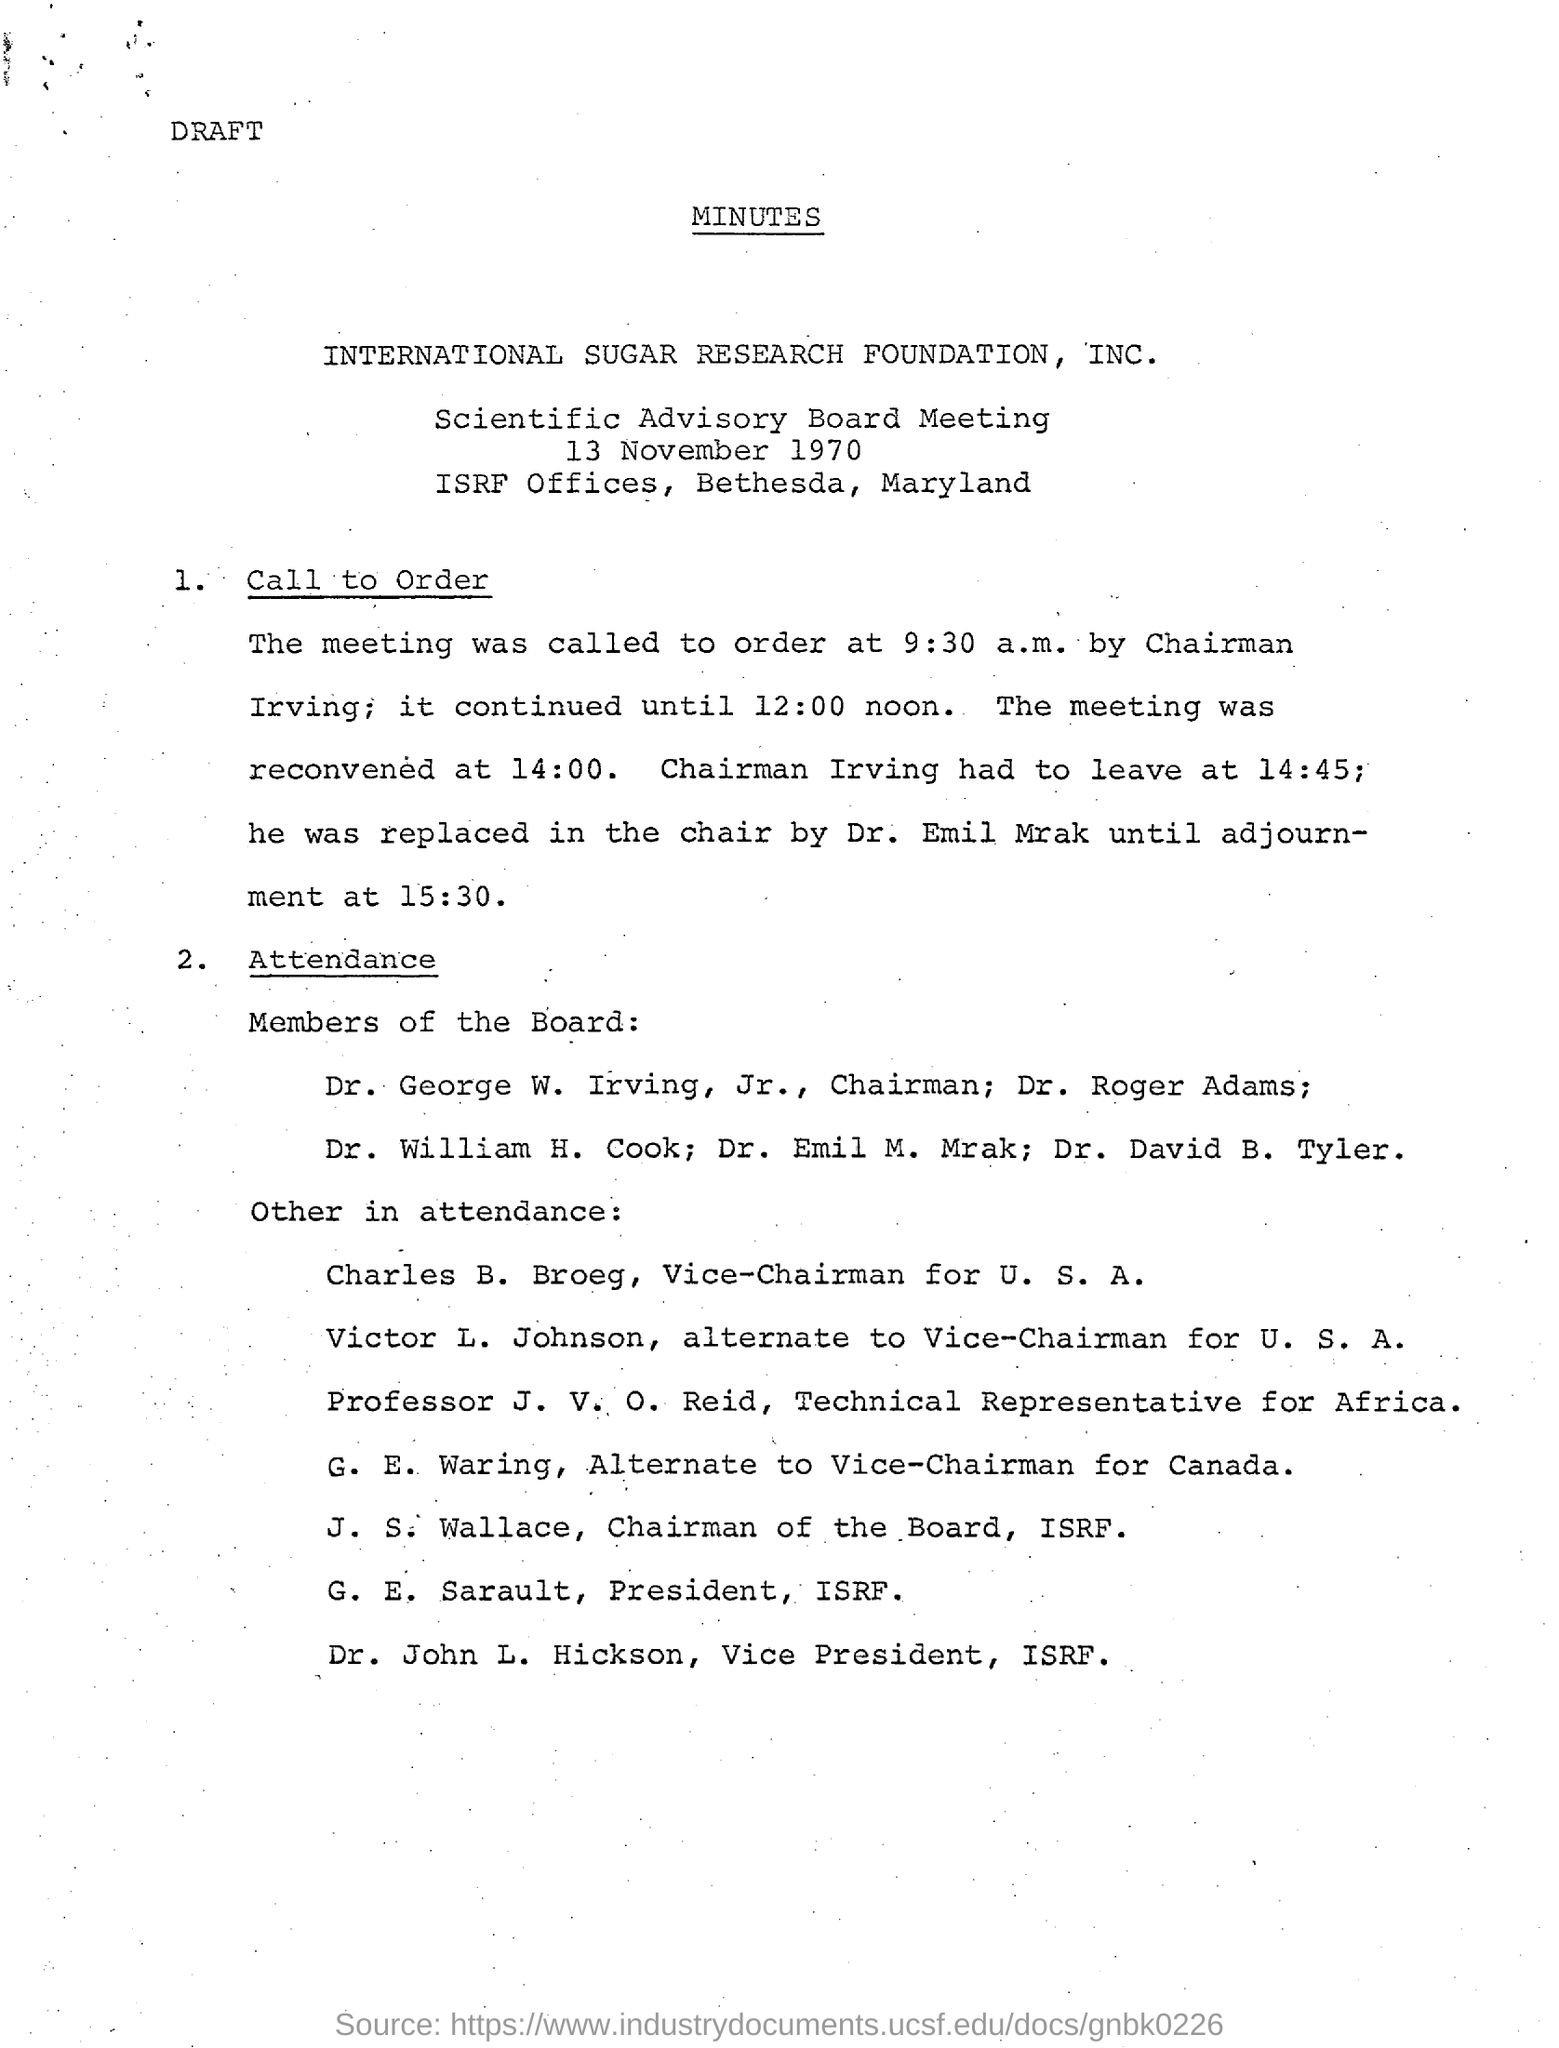Specify some key components in this picture. Chairman Irving left at 2:45 PM. The meeting was called to order at 9:30 am. The meeting was reconvened at 14:00. The meeting was called to order by the chairman, Irving. The adjournment took place at 3:30 PM. 